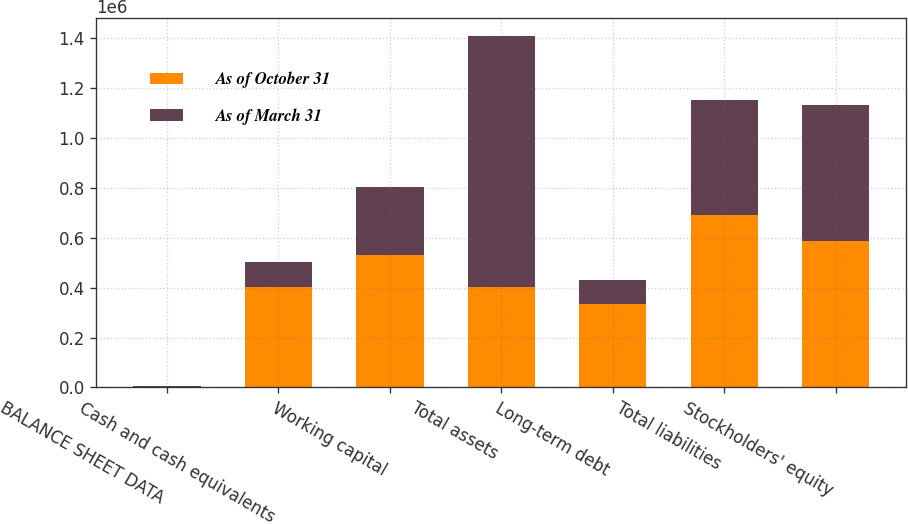Convert chart. <chart><loc_0><loc_0><loc_500><loc_500><stacked_bar_chart><ecel><fcel>BALANCE SHEET DATA<fcel>Cash and cash equivalents<fcel>Working capital<fcel>Total assets<fcel>Long-term debt<fcel>Total liabilities<fcel>Stockholders' equity<nl><fcel>As of October 31<fcel>2013<fcel>402502<fcel>529153<fcel>402502<fcel>335202<fcel>689844<fcel>587995<nl><fcel>As of March 31<fcel>2009<fcel>102083<fcel>274274<fcel>1.00713e+06<fcel>97063<fcel>461502<fcel>545626<nl></chart> 